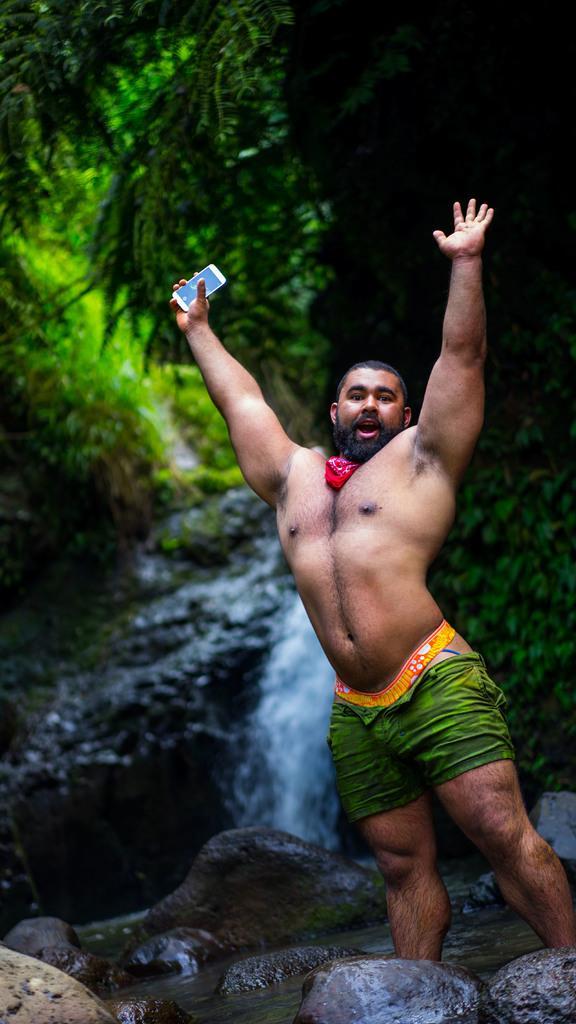Can you describe this image briefly? In this picture I can see man standing and holding a mobile in his hand and I can see water flowing from the rocks and I can see trees. 